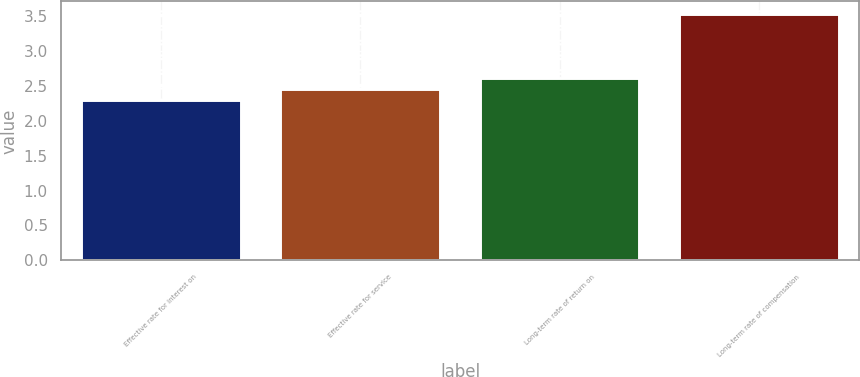Convert chart. <chart><loc_0><loc_0><loc_500><loc_500><bar_chart><fcel>Effective rate for interest on<fcel>Effective rate for service<fcel>Long-term rate of return on<fcel>Long-term rate of compensation<nl><fcel>2.29<fcel>2.45<fcel>2.61<fcel>3.53<nl></chart> 